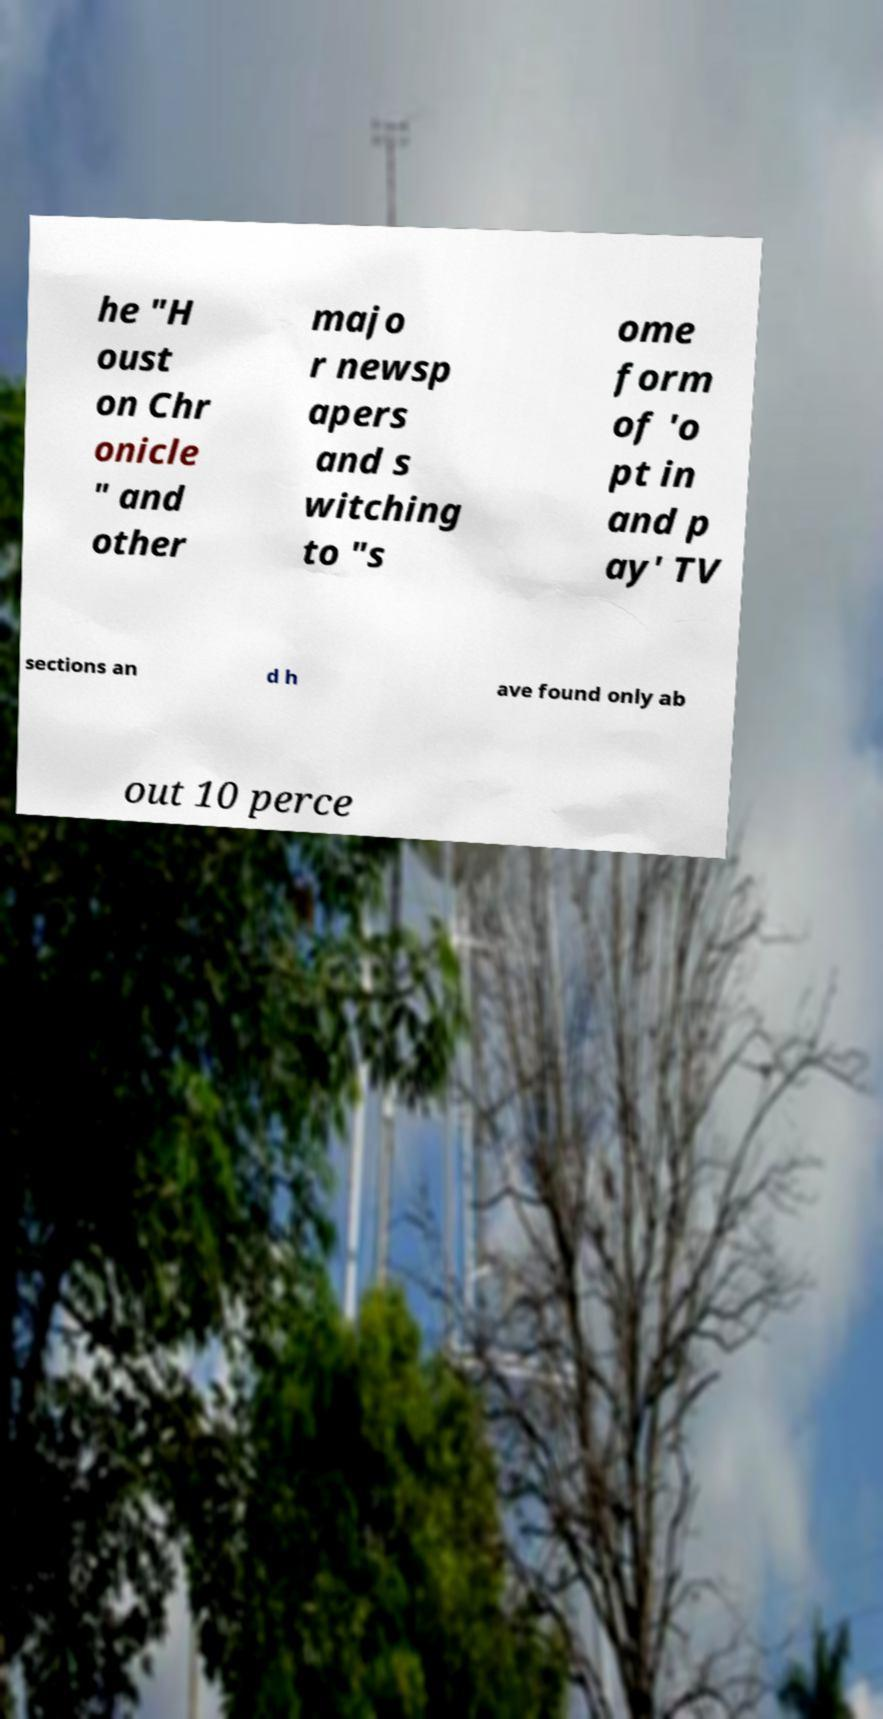There's text embedded in this image that I need extracted. Can you transcribe it verbatim? he "H oust on Chr onicle " and other majo r newsp apers and s witching to "s ome form of 'o pt in and p ay' TV sections an d h ave found only ab out 10 perce 